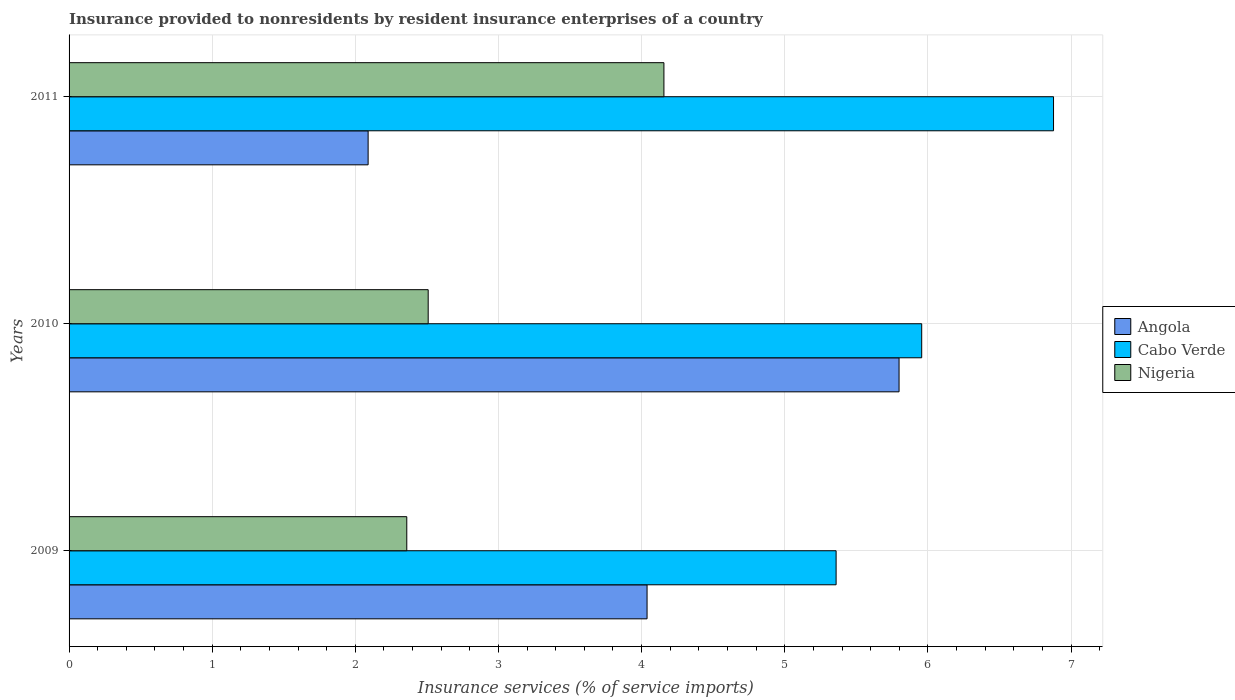How many different coloured bars are there?
Your answer should be very brief. 3. How many groups of bars are there?
Offer a terse response. 3. Are the number of bars per tick equal to the number of legend labels?
Offer a terse response. Yes. How many bars are there on the 1st tick from the top?
Give a very brief answer. 3. What is the label of the 1st group of bars from the top?
Ensure brevity in your answer.  2011. In how many cases, is the number of bars for a given year not equal to the number of legend labels?
Ensure brevity in your answer.  0. What is the insurance provided to nonresidents in Cabo Verde in 2009?
Offer a terse response. 5.36. Across all years, what is the maximum insurance provided to nonresidents in Angola?
Your answer should be very brief. 5.8. Across all years, what is the minimum insurance provided to nonresidents in Angola?
Keep it short and to the point. 2.09. In which year was the insurance provided to nonresidents in Cabo Verde maximum?
Your answer should be compact. 2011. In which year was the insurance provided to nonresidents in Nigeria minimum?
Your answer should be very brief. 2009. What is the total insurance provided to nonresidents in Nigeria in the graph?
Make the answer very short. 9.02. What is the difference between the insurance provided to nonresidents in Cabo Verde in 2009 and that in 2011?
Your answer should be compact. -1.52. What is the difference between the insurance provided to nonresidents in Cabo Verde in 2009 and the insurance provided to nonresidents in Nigeria in 2011?
Your answer should be very brief. 1.2. What is the average insurance provided to nonresidents in Cabo Verde per year?
Offer a terse response. 6.06. In the year 2011, what is the difference between the insurance provided to nonresidents in Angola and insurance provided to nonresidents in Cabo Verde?
Provide a succinct answer. -4.79. What is the ratio of the insurance provided to nonresidents in Nigeria in 2009 to that in 2011?
Keep it short and to the point. 0.57. Is the insurance provided to nonresidents in Angola in 2010 less than that in 2011?
Provide a short and direct response. No. Is the difference between the insurance provided to nonresidents in Angola in 2010 and 2011 greater than the difference between the insurance provided to nonresidents in Cabo Verde in 2010 and 2011?
Your answer should be very brief. Yes. What is the difference between the highest and the second highest insurance provided to nonresidents in Angola?
Provide a succinct answer. 1.76. What is the difference between the highest and the lowest insurance provided to nonresidents in Cabo Verde?
Make the answer very short. 1.52. What does the 1st bar from the top in 2011 represents?
Make the answer very short. Nigeria. What does the 2nd bar from the bottom in 2009 represents?
Offer a terse response. Cabo Verde. Is it the case that in every year, the sum of the insurance provided to nonresidents in Cabo Verde and insurance provided to nonresidents in Nigeria is greater than the insurance provided to nonresidents in Angola?
Offer a very short reply. Yes. How many bars are there?
Offer a very short reply. 9. How many years are there in the graph?
Give a very brief answer. 3. What is the difference between two consecutive major ticks on the X-axis?
Ensure brevity in your answer.  1. Are the values on the major ticks of X-axis written in scientific E-notation?
Your response must be concise. No. Does the graph contain any zero values?
Provide a succinct answer. No. Does the graph contain grids?
Provide a short and direct response. Yes. How many legend labels are there?
Offer a terse response. 3. How are the legend labels stacked?
Ensure brevity in your answer.  Vertical. What is the title of the graph?
Keep it short and to the point. Insurance provided to nonresidents by resident insurance enterprises of a country. What is the label or title of the X-axis?
Give a very brief answer. Insurance services (% of service imports). What is the label or title of the Y-axis?
Offer a very short reply. Years. What is the Insurance services (% of service imports) of Angola in 2009?
Your answer should be compact. 4.04. What is the Insurance services (% of service imports) in Cabo Verde in 2009?
Offer a very short reply. 5.36. What is the Insurance services (% of service imports) of Nigeria in 2009?
Your answer should be compact. 2.36. What is the Insurance services (% of service imports) of Angola in 2010?
Your response must be concise. 5.8. What is the Insurance services (% of service imports) of Cabo Verde in 2010?
Your answer should be very brief. 5.96. What is the Insurance services (% of service imports) in Nigeria in 2010?
Provide a succinct answer. 2.51. What is the Insurance services (% of service imports) in Angola in 2011?
Give a very brief answer. 2.09. What is the Insurance services (% of service imports) of Cabo Verde in 2011?
Your answer should be compact. 6.88. What is the Insurance services (% of service imports) of Nigeria in 2011?
Keep it short and to the point. 4.16. Across all years, what is the maximum Insurance services (% of service imports) of Angola?
Offer a very short reply. 5.8. Across all years, what is the maximum Insurance services (% of service imports) of Cabo Verde?
Provide a short and direct response. 6.88. Across all years, what is the maximum Insurance services (% of service imports) of Nigeria?
Offer a terse response. 4.16. Across all years, what is the minimum Insurance services (% of service imports) in Angola?
Ensure brevity in your answer.  2.09. Across all years, what is the minimum Insurance services (% of service imports) in Cabo Verde?
Your answer should be compact. 5.36. Across all years, what is the minimum Insurance services (% of service imports) of Nigeria?
Offer a very short reply. 2.36. What is the total Insurance services (% of service imports) of Angola in the graph?
Your answer should be very brief. 11.93. What is the total Insurance services (% of service imports) in Cabo Verde in the graph?
Your answer should be compact. 18.19. What is the total Insurance services (% of service imports) of Nigeria in the graph?
Provide a short and direct response. 9.02. What is the difference between the Insurance services (% of service imports) of Angola in 2009 and that in 2010?
Make the answer very short. -1.76. What is the difference between the Insurance services (% of service imports) of Cabo Verde in 2009 and that in 2010?
Your answer should be compact. -0.6. What is the difference between the Insurance services (% of service imports) of Nigeria in 2009 and that in 2010?
Keep it short and to the point. -0.15. What is the difference between the Insurance services (% of service imports) of Angola in 2009 and that in 2011?
Provide a succinct answer. 1.95. What is the difference between the Insurance services (% of service imports) of Cabo Verde in 2009 and that in 2011?
Offer a terse response. -1.52. What is the difference between the Insurance services (% of service imports) of Nigeria in 2009 and that in 2011?
Ensure brevity in your answer.  -1.8. What is the difference between the Insurance services (% of service imports) of Angola in 2010 and that in 2011?
Your response must be concise. 3.71. What is the difference between the Insurance services (% of service imports) of Cabo Verde in 2010 and that in 2011?
Offer a terse response. -0.92. What is the difference between the Insurance services (% of service imports) of Nigeria in 2010 and that in 2011?
Make the answer very short. -1.65. What is the difference between the Insurance services (% of service imports) in Angola in 2009 and the Insurance services (% of service imports) in Cabo Verde in 2010?
Provide a succinct answer. -1.92. What is the difference between the Insurance services (% of service imports) in Angola in 2009 and the Insurance services (% of service imports) in Nigeria in 2010?
Keep it short and to the point. 1.53. What is the difference between the Insurance services (% of service imports) of Cabo Verde in 2009 and the Insurance services (% of service imports) of Nigeria in 2010?
Your answer should be very brief. 2.85. What is the difference between the Insurance services (% of service imports) of Angola in 2009 and the Insurance services (% of service imports) of Cabo Verde in 2011?
Give a very brief answer. -2.84. What is the difference between the Insurance services (% of service imports) of Angola in 2009 and the Insurance services (% of service imports) of Nigeria in 2011?
Make the answer very short. -0.12. What is the difference between the Insurance services (% of service imports) of Cabo Verde in 2009 and the Insurance services (% of service imports) of Nigeria in 2011?
Offer a terse response. 1.2. What is the difference between the Insurance services (% of service imports) in Angola in 2010 and the Insurance services (% of service imports) in Cabo Verde in 2011?
Offer a terse response. -1.08. What is the difference between the Insurance services (% of service imports) in Angola in 2010 and the Insurance services (% of service imports) in Nigeria in 2011?
Provide a short and direct response. 1.64. What is the difference between the Insurance services (% of service imports) in Cabo Verde in 2010 and the Insurance services (% of service imports) in Nigeria in 2011?
Your answer should be very brief. 1.8. What is the average Insurance services (% of service imports) in Angola per year?
Provide a short and direct response. 3.98. What is the average Insurance services (% of service imports) in Cabo Verde per year?
Give a very brief answer. 6.06. What is the average Insurance services (% of service imports) in Nigeria per year?
Offer a very short reply. 3.01. In the year 2009, what is the difference between the Insurance services (% of service imports) of Angola and Insurance services (% of service imports) of Cabo Verde?
Provide a succinct answer. -1.32. In the year 2009, what is the difference between the Insurance services (% of service imports) in Angola and Insurance services (% of service imports) in Nigeria?
Keep it short and to the point. 1.68. In the year 2009, what is the difference between the Insurance services (% of service imports) in Cabo Verde and Insurance services (% of service imports) in Nigeria?
Offer a very short reply. 3. In the year 2010, what is the difference between the Insurance services (% of service imports) in Angola and Insurance services (% of service imports) in Cabo Verde?
Give a very brief answer. -0.16. In the year 2010, what is the difference between the Insurance services (% of service imports) in Angola and Insurance services (% of service imports) in Nigeria?
Offer a very short reply. 3.29. In the year 2010, what is the difference between the Insurance services (% of service imports) of Cabo Verde and Insurance services (% of service imports) of Nigeria?
Offer a very short reply. 3.45. In the year 2011, what is the difference between the Insurance services (% of service imports) of Angola and Insurance services (% of service imports) of Cabo Verde?
Make the answer very short. -4.79. In the year 2011, what is the difference between the Insurance services (% of service imports) in Angola and Insurance services (% of service imports) in Nigeria?
Give a very brief answer. -2.07. In the year 2011, what is the difference between the Insurance services (% of service imports) in Cabo Verde and Insurance services (% of service imports) in Nigeria?
Make the answer very short. 2.72. What is the ratio of the Insurance services (% of service imports) in Angola in 2009 to that in 2010?
Your answer should be very brief. 0.7. What is the ratio of the Insurance services (% of service imports) of Cabo Verde in 2009 to that in 2010?
Provide a succinct answer. 0.9. What is the ratio of the Insurance services (% of service imports) in Nigeria in 2009 to that in 2010?
Give a very brief answer. 0.94. What is the ratio of the Insurance services (% of service imports) in Angola in 2009 to that in 2011?
Offer a terse response. 1.93. What is the ratio of the Insurance services (% of service imports) in Cabo Verde in 2009 to that in 2011?
Give a very brief answer. 0.78. What is the ratio of the Insurance services (% of service imports) in Nigeria in 2009 to that in 2011?
Give a very brief answer. 0.57. What is the ratio of the Insurance services (% of service imports) in Angola in 2010 to that in 2011?
Your answer should be very brief. 2.78. What is the ratio of the Insurance services (% of service imports) of Cabo Verde in 2010 to that in 2011?
Your response must be concise. 0.87. What is the ratio of the Insurance services (% of service imports) in Nigeria in 2010 to that in 2011?
Your answer should be very brief. 0.6. What is the difference between the highest and the second highest Insurance services (% of service imports) of Angola?
Your answer should be very brief. 1.76. What is the difference between the highest and the second highest Insurance services (% of service imports) of Cabo Verde?
Your response must be concise. 0.92. What is the difference between the highest and the second highest Insurance services (% of service imports) of Nigeria?
Keep it short and to the point. 1.65. What is the difference between the highest and the lowest Insurance services (% of service imports) in Angola?
Provide a short and direct response. 3.71. What is the difference between the highest and the lowest Insurance services (% of service imports) of Cabo Verde?
Keep it short and to the point. 1.52. What is the difference between the highest and the lowest Insurance services (% of service imports) in Nigeria?
Offer a very short reply. 1.8. 